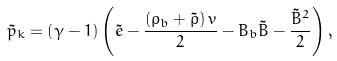<formula> <loc_0><loc_0><loc_500><loc_500>\tilde { p } _ { k } = \left ( \gamma - 1 \right ) \left ( \tilde { e } - \frac { \left ( \rho _ { b } + \tilde { \rho } \right ) { v } } { 2 } - { B } _ { b } { \tilde { B } } - \frac { { \tilde { B } } ^ { 2 } } { 2 } \right ) ,</formula> 